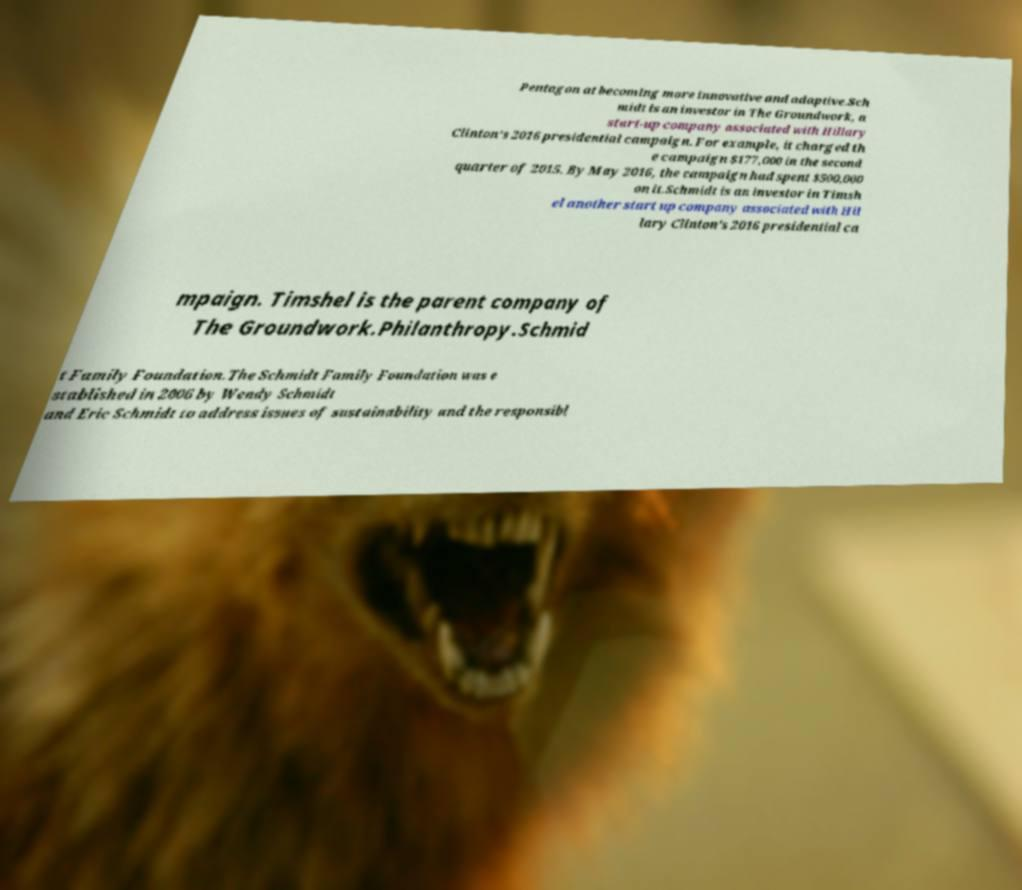Please read and relay the text visible in this image. What does it say? Pentagon at becoming more innovative and adaptive.Sch midt is an investor in The Groundwork, a start-up company associated with Hillary Clinton's 2016 presidential campaign. For example, it charged th e campaign $177,000 in the second quarter of 2015. By May 2016, the campaign had spent $500,000 on it.Schmidt is an investor in Timsh el another start up company associated with Hil lary Clinton's 2016 presidential ca mpaign. Timshel is the parent company of The Groundwork.Philanthropy.Schmid t Family Foundation.The Schmidt Family Foundation was e stablished in 2006 by Wendy Schmidt and Eric Schmidt to address issues of sustainability and the responsibl 